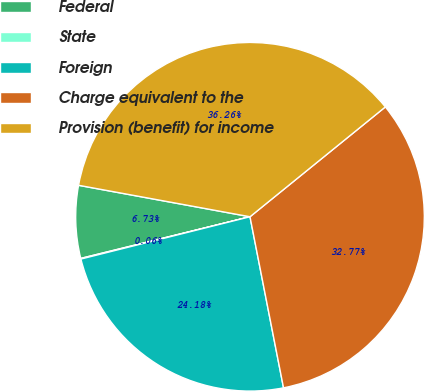Convert chart to OTSL. <chart><loc_0><loc_0><loc_500><loc_500><pie_chart><fcel>Federal<fcel>State<fcel>Foreign<fcel>Charge equivalent to the<fcel>Provision (benefit) for income<nl><fcel>6.73%<fcel>0.06%<fcel>24.18%<fcel>32.77%<fcel>36.26%<nl></chart> 